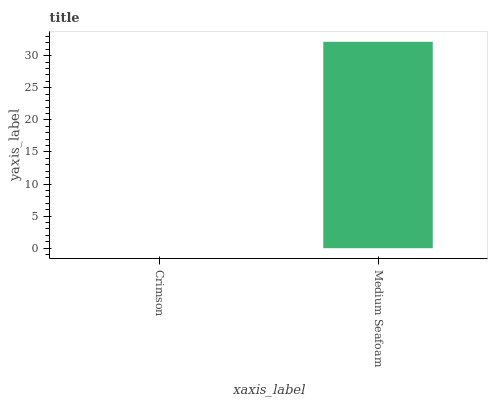Is Medium Seafoam the minimum?
Answer yes or no. No. Is Medium Seafoam greater than Crimson?
Answer yes or no. Yes. Is Crimson less than Medium Seafoam?
Answer yes or no. Yes. Is Crimson greater than Medium Seafoam?
Answer yes or no. No. Is Medium Seafoam less than Crimson?
Answer yes or no. No. Is Medium Seafoam the high median?
Answer yes or no. Yes. Is Crimson the low median?
Answer yes or no. Yes. Is Crimson the high median?
Answer yes or no. No. Is Medium Seafoam the low median?
Answer yes or no. No. 